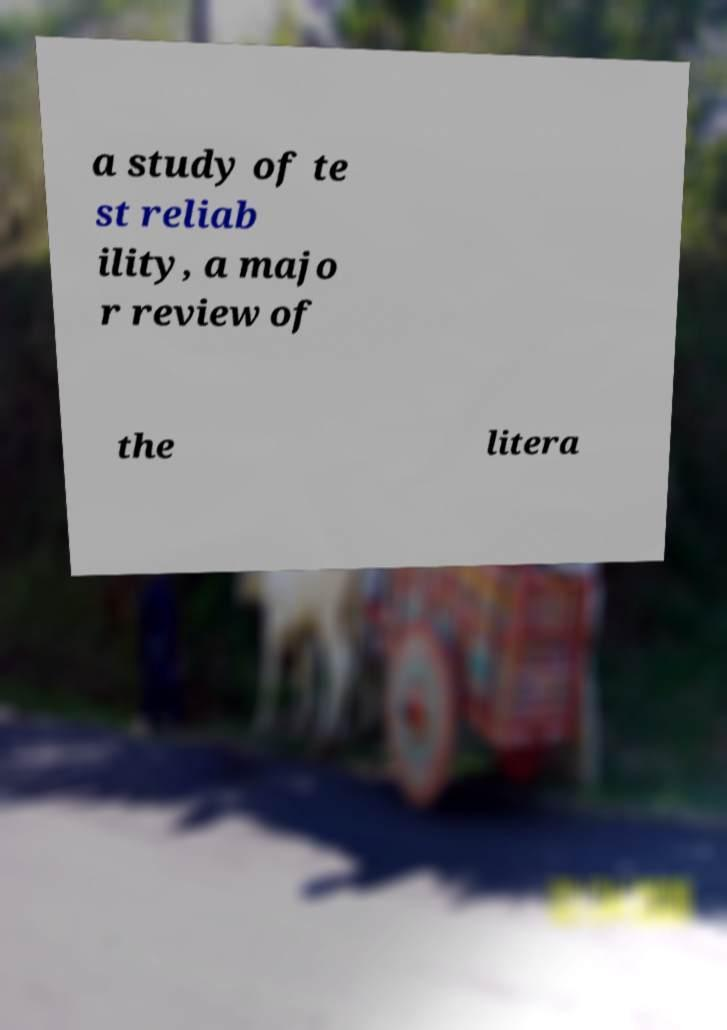Can you accurately transcribe the text from the provided image for me? a study of te st reliab ility, a majo r review of the litera 